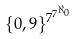<formula> <loc_0><loc_0><loc_500><loc_500>\{ 0 , 9 \} ^ { 7 ^ { 7 ^ { \aleph _ { 0 } } } }</formula> 